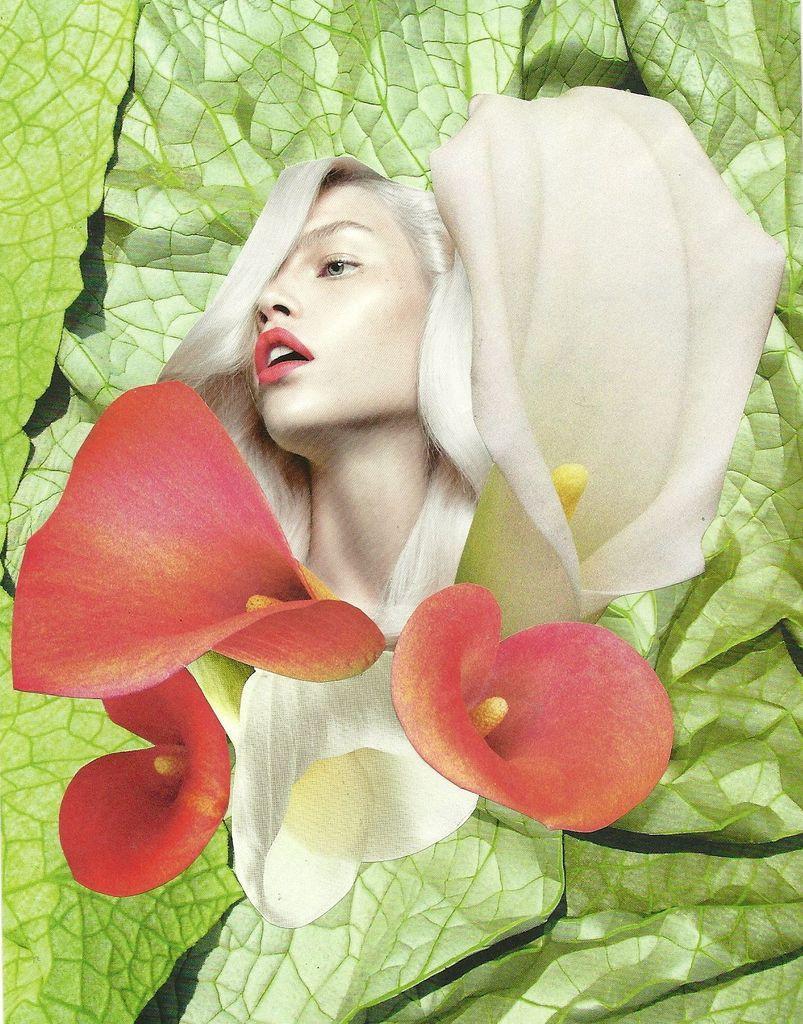In one or two sentences, can you explain what this image depicts? In this image I can see woman face. I can see flowers. They are in white and red color. Background is green in color. 